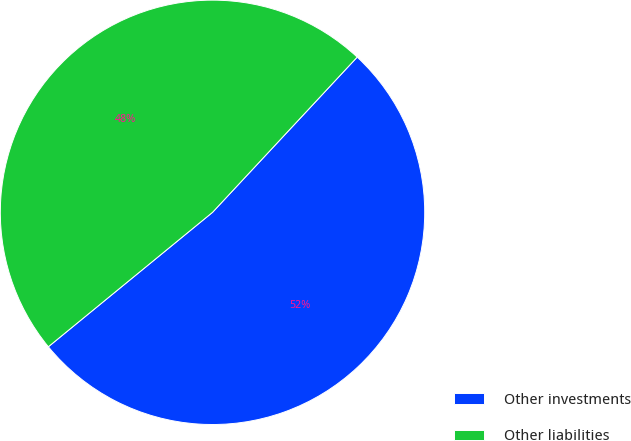<chart> <loc_0><loc_0><loc_500><loc_500><pie_chart><fcel>Other investments<fcel>Other liabilities<nl><fcel>52.14%<fcel>47.86%<nl></chart> 